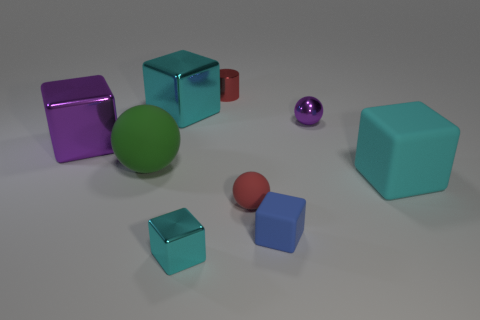How many cyan blocks must be subtracted to get 1 cyan blocks? 2 Subtract all yellow spheres. How many cyan cubes are left? 3 Subtract 2 blocks. How many blocks are left? 3 Subtract all blue cubes. How many cubes are left? 4 Subtract all tiny cyan cubes. How many cubes are left? 4 Add 1 big yellow cylinders. How many objects exist? 10 Subtract all purple blocks. Subtract all yellow cylinders. How many blocks are left? 4 Subtract all balls. How many objects are left? 6 Add 3 small red balls. How many small red balls exist? 4 Subtract 0 yellow cylinders. How many objects are left? 9 